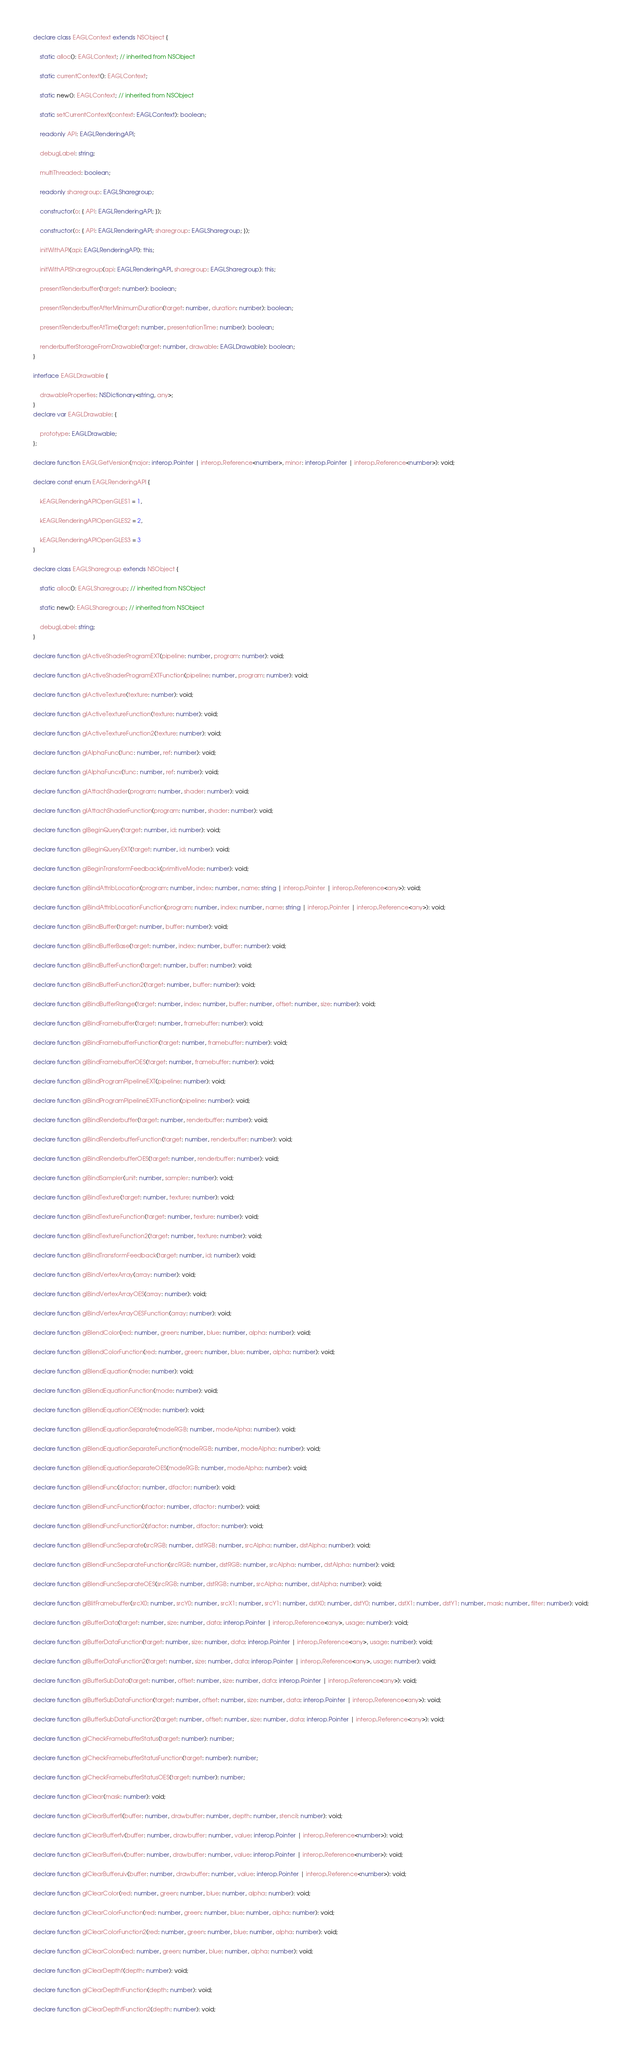Convert code to text. <code><loc_0><loc_0><loc_500><loc_500><_TypeScript_>
declare class EAGLContext extends NSObject {

	static alloc(): EAGLContext; // inherited from NSObject

	static currentContext(): EAGLContext;

	static new(): EAGLContext; // inherited from NSObject

	static setCurrentContext(context: EAGLContext): boolean;

	readonly API: EAGLRenderingAPI;

	debugLabel: string;

	multiThreaded: boolean;

	readonly sharegroup: EAGLSharegroup;

	constructor(o: { API: EAGLRenderingAPI; });

	constructor(o: { API: EAGLRenderingAPI; sharegroup: EAGLSharegroup; });

	initWithAPI(api: EAGLRenderingAPI): this;

	initWithAPISharegroup(api: EAGLRenderingAPI, sharegroup: EAGLSharegroup): this;

	presentRenderbuffer(target: number): boolean;

	presentRenderbufferAfterMinimumDuration(target: number, duration: number): boolean;

	presentRenderbufferAtTime(target: number, presentationTime: number): boolean;

	renderbufferStorageFromDrawable(target: number, drawable: EAGLDrawable): boolean;
}

interface EAGLDrawable {

	drawableProperties: NSDictionary<string, any>;
}
declare var EAGLDrawable: {

	prototype: EAGLDrawable;
};

declare function EAGLGetVersion(major: interop.Pointer | interop.Reference<number>, minor: interop.Pointer | interop.Reference<number>): void;

declare const enum EAGLRenderingAPI {

	kEAGLRenderingAPIOpenGLES1 = 1,

	kEAGLRenderingAPIOpenGLES2 = 2,

	kEAGLRenderingAPIOpenGLES3 = 3
}

declare class EAGLSharegroup extends NSObject {

	static alloc(): EAGLSharegroup; // inherited from NSObject

	static new(): EAGLSharegroup; // inherited from NSObject

	debugLabel: string;
}

declare function glActiveShaderProgramEXT(pipeline: number, program: number): void;

declare function glActiveShaderProgramEXTFunction(pipeline: number, program: number): void;

declare function glActiveTexture(texture: number): void;

declare function glActiveTextureFunction(texture: number): void;

declare function glActiveTextureFunction2(texture: number): void;

declare function glAlphaFunc(func: number, ref: number): void;

declare function glAlphaFuncx(func: number, ref: number): void;

declare function glAttachShader(program: number, shader: number): void;

declare function glAttachShaderFunction(program: number, shader: number): void;

declare function glBeginQuery(target: number, id: number): void;

declare function glBeginQueryEXT(target: number, id: number): void;

declare function glBeginTransformFeedback(primitiveMode: number): void;

declare function glBindAttribLocation(program: number, index: number, name: string | interop.Pointer | interop.Reference<any>): void;

declare function glBindAttribLocationFunction(program: number, index: number, name: string | interop.Pointer | interop.Reference<any>): void;

declare function glBindBuffer(target: number, buffer: number): void;

declare function glBindBufferBase(target: number, index: number, buffer: number): void;

declare function glBindBufferFunction(target: number, buffer: number): void;

declare function glBindBufferFunction2(target: number, buffer: number): void;

declare function glBindBufferRange(target: number, index: number, buffer: number, offset: number, size: number): void;

declare function glBindFramebuffer(target: number, framebuffer: number): void;

declare function glBindFramebufferFunction(target: number, framebuffer: number): void;

declare function glBindFramebufferOES(target: number, framebuffer: number): void;

declare function glBindProgramPipelineEXT(pipeline: number): void;

declare function glBindProgramPipelineEXTFunction(pipeline: number): void;

declare function glBindRenderbuffer(target: number, renderbuffer: number): void;

declare function glBindRenderbufferFunction(target: number, renderbuffer: number): void;

declare function glBindRenderbufferOES(target: number, renderbuffer: number): void;

declare function glBindSampler(unit: number, sampler: number): void;

declare function glBindTexture(target: number, texture: number): void;

declare function glBindTextureFunction(target: number, texture: number): void;

declare function glBindTextureFunction2(target: number, texture: number): void;

declare function glBindTransformFeedback(target: number, id: number): void;

declare function glBindVertexArray(array: number): void;

declare function glBindVertexArrayOES(array: number): void;

declare function glBindVertexArrayOESFunction(array: number): void;

declare function glBlendColor(red: number, green: number, blue: number, alpha: number): void;

declare function glBlendColorFunction(red: number, green: number, blue: number, alpha: number): void;

declare function glBlendEquation(mode: number): void;

declare function glBlendEquationFunction(mode: number): void;

declare function glBlendEquationOES(mode: number): void;

declare function glBlendEquationSeparate(modeRGB: number, modeAlpha: number): void;

declare function glBlendEquationSeparateFunction(modeRGB: number, modeAlpha: number): void;

declare function glBlendEquationSeparateOES(modeRGB: number, modeAlpha: number): void;

declare function glBlendFunc(sfactor: number, dfactor: number): void;

declare function glBlendFuncFunction(sfactor: number, dfactor: number): void;

declare function glBlendFuncFunction2(sfactor: number, dfactor: number): void;

declare function glBlendFuncSeparate(srcRGB: number, dstRGB: number, srcAlpha: number, dstAlpha: number): void;

declare function glBlendFuncSeparateFunction(srcRGB: number, dstRGB: number, srcAlpha: number, dstAlpha: number): void;

declare function glBlendFuncSeparateOES(srcRGB: number, dstRGB: number, srcAlpha: number, dstAlpha: number): void;

declare function glBlitFramebuffer(srcX0: number, srcY0: number, srcX1: number, srcY1: number, dstX0: number, dstY0: number, dstX1: number, dstY1: number, mask: number, filter: number): void;

declare function glBufferData(target: number, size: number, data: interop.Pointer | interop.Reference<any>, usage: number): void;

declare function glBufferDataFunction(target: number, size: number, data: interop.Pointer | interop.Reference<any>, usage: number): void;

declare function glBufferDataFunction2(target: number, size: number, data: interop.Pointer | interop.Reference<any>, usage: number): void;

declare function glBufferSubData(target: number, offset: number, size: number, data: interop.Pointer | interop.Reference<any>): void;

declare function glBufferSubDataFunction(target: number, offset: number, size: number, data: interop.Pointer | interop.Reference<any>): void;

declare function glBufferSubDataFunction2(target: number, offset: number, size: number, data: interop.Pointer | interop.Reference<any>): void;

declare function glCheckFramebufferStatus(target: number): number;

declare function glCheckFramebufferStatusFunction(target: number): number;

declare function glCheckFramebufferStatusOES(target: number): number;

declare function glClear(mask: number): void;

declare function glClearBufferfi(buffer: number, drawbuffer: number, depth: number, stencil: number): void;

declare function glClearBufferfv(buffer: number, drawbuffer: number, value: interop.Pointer | interop.Reference<number>): void;

declare function glClearBufferiv(buffer: number, drawbuffer: number, value: interop.Pointer | interop.Reference<number>): void;

declare function glClearBufferuiv(buffer: number, drawbuffer: number, value: interop.Pointer | interop.Reference<number>): void;

declare function glClearColor(red: number, green: number, blue: number, alpha: number): void;

declare function glClearColorFunction(red: number, green: number, blue: number, alpha: number): void;

declare function glClearColorFunction2(red: number, green: number, blue: number, alpha: number): void;

declare function glClearColorx(red: number, green: number, blue: number, alpha: number): void;

declare function glClearDepthf(depth: number): void;

declare function glClearDepthfFunction(depth: number): void;

declare function glClearDepthfFunction2(depth: number): void;
</code> 